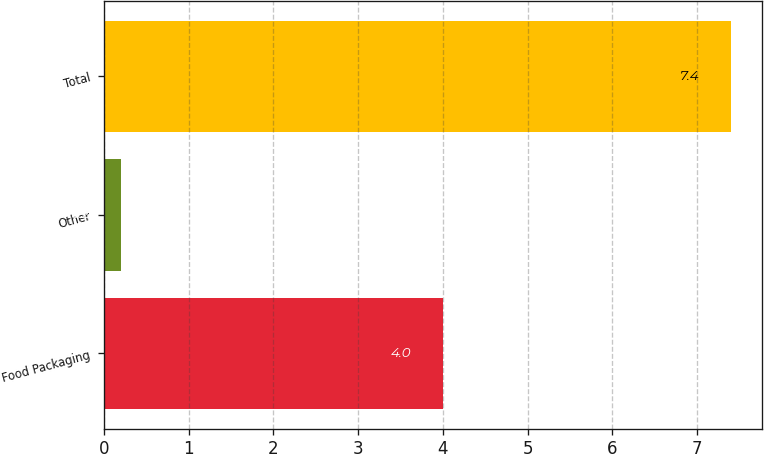Convert chart. <chart><loc_0><loc_0><loc_500><loc_500><bar_chart><fcel>Food Packaging<fcel>Other<fcel>Total<nl><fcel>4<fcel>0.2<fcel>7.4<nl></chart> 